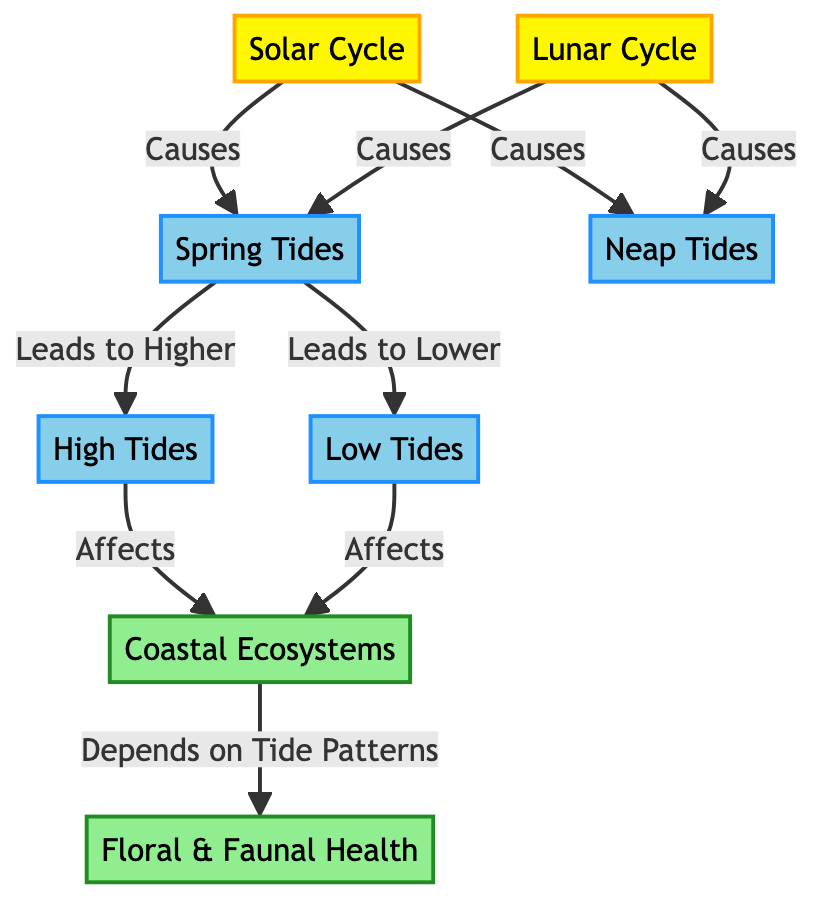What are the two cycles that influence tides? The diagram indicates that both the Solar Cycle and Lunar Cycle are responsible for influencing tides. These two cycles are connected through various interactions leading to different tidal conditions.
Answer: Solar Cycle, Lunar Cycle Which tides do spring tides lead to? According to the diagram, spring tides lead to higher tides and lower tides, indicating the specific conditions created during spring tides that result in these tidal variations.
Answer: Higher, Lower What is the relationship between high tides and coastal ecosystems? The diagram shows a direct effect, stating that high tides affect coastal ecosystems. This suggests that the presence and level of high tides have implications for the health and dynamics of coastal environments.
Answer: Affects How many types of tides are mentioned in the diagram? The diagram clearly lists four types of tides: spring tides, neap tides, high tides, and low tides. Counting these elements reveals a total of four distinct types of tides.
Answer: Four What aspect of coastal ecosystems depends on tide patterns? The diagram specifically states that floral and faunal health depends on tide patterns, highlighting an ecological link that illustrates the importance of tides for the well-being of living organisms in coastal habitats.
Answer: Floral & Faunal Health What effect do neap tides have according to the solar and lunar cycles? Neap tides are caused by both the solar cycle and lunar cycle, indicating a bi-directional influence that affects tidal conditions, demonstrating how both cycles contribute to this specific type of tide.
Answer: Causes What do high tides and low tides both affect? The diagram shows that both high tides and low tides affect coastal ecosystems. This relationship emphasizes the importance of both tidal extremes on ecological systems in coastal regions.
Answer: Coastal Ecosystems Which component of the diagram links floral and faunal health to coastal ecosystems? The diagram specifies that floral and faunal health is associated with coastal ecosystems, establishing a direct connection that highlights the interdependency between these ecological elements and their surrounding environments.
Answer: Depends on Tide Patterns 